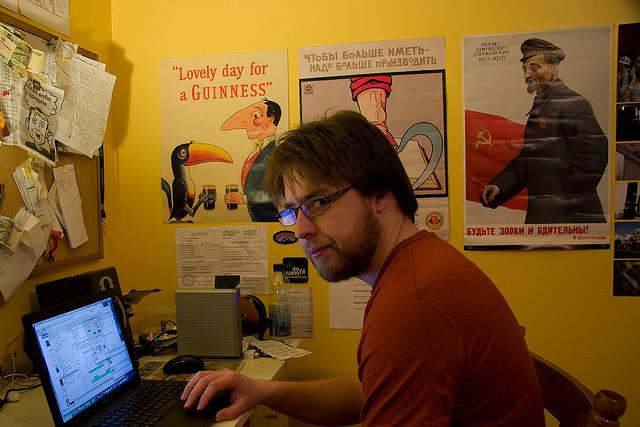What are the toucan and the man going to enjoy? guinness 